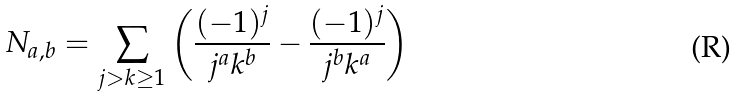<formula> <loc_0><loc_0><loc_500><loc_500>N _ { a , b } = \sum _ { j > k \geq 1 } \left ( \frac { ( - 1 ) ^ { j } } { j ^ { a } k ^ { b } } - \frac { ( - 1 ) ^ { j } } { j ^ { b } k ^ { a } } \right )</formula> 